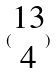Convert formula to latex. <formula><loc_0><loc_0><loc_500><loc_500>( \begin{matrix} 1 3 \\ 4 \end{matrix} )</formula> 